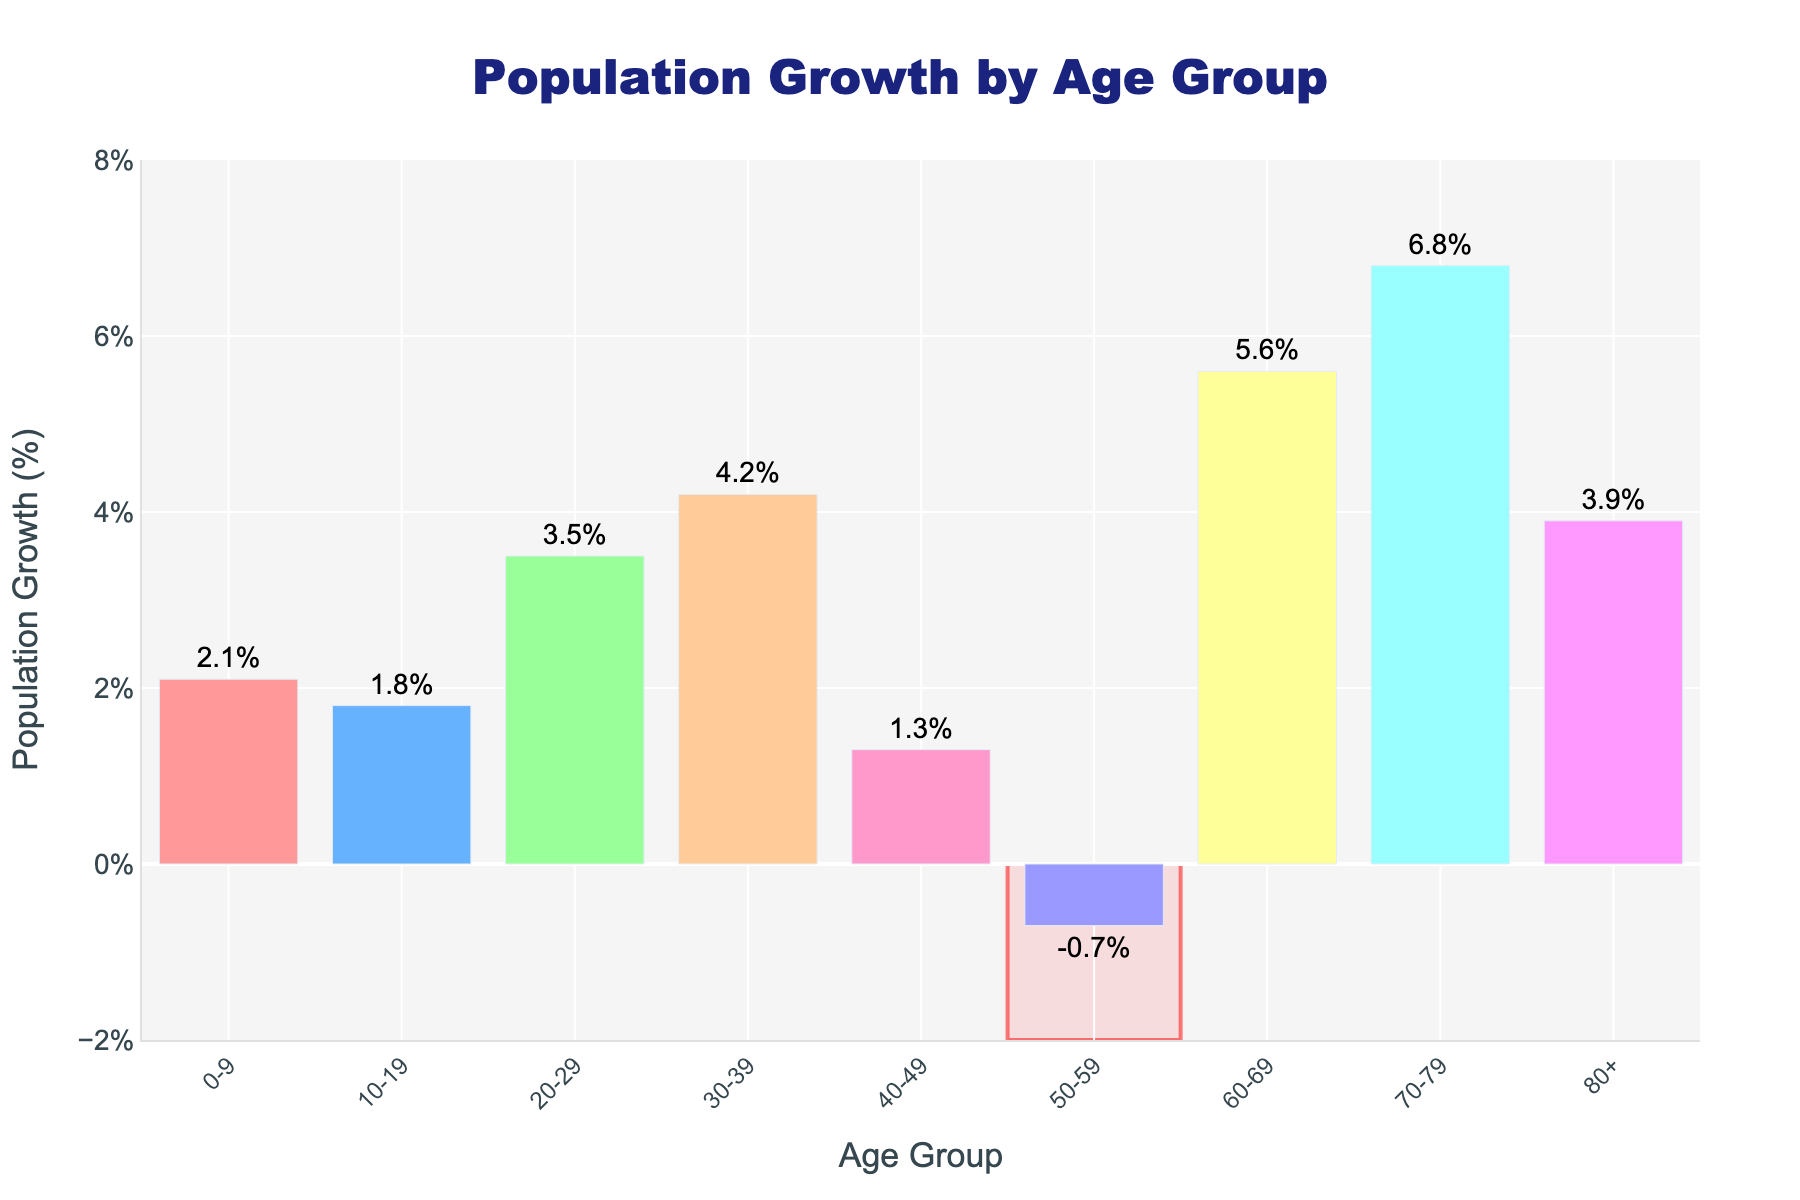Which age group experienced the highest population growth? Refer to the height of the bars and identify the tallest one. The tallest bar represents the age group 70-79.
Answer: 70-79 Which age group experienced a decline in population growth? Look for the bar below the y-axis, indicating a negative value. The bar representing the age group 50-59 is the only one below 0%.
Answer: 50-59 What is the difference in population growth between the age group 30-39 and 40-49? Find the heights of the bars for 30-39 (4.2%) and 40-49 (1.3%). Then, subtract 1.3% from 4.2%.
Answer: 2.9% Which age group had the closest population growth to 4%? Find the bar heights near 4%. The closest one is for the age group 80+, which has a growth of 3.9%.
Answer: 80+ Calculate the average population growth for the age groups 20-29, 30-39, and 40-49. Sum their growth rates (3.5% + 4.2% + 1.3% = 9%) and divide by the number of age groups (9%/3).
Answer: 3% Compare the population growth of the age groups 0-9 and 60-69. Which one had a higher growth rate? Identify the bar heights for 0-9 (2.1%) and 60-69 (5.6%). The bar for 60-69 is taller, meaning its growth rate is higher.
Answer: 60-69 What is the combined population growth percentage for age groups 0-9 and 10-19? Sum their growth rates (2.1% + 1.8%).
Answer: 3.9% How many age groups have a population growth of 3% or more? Count the bars that reach or exceed 3%: 20-29, 30-39, 60-69, 70-79, 80+. There are five age groups.
Answer: 5 Is the population growth rate for the age group 80+ higher or lower than the growth rate for the age group 10-19? Compare their heights: 80+ has a growth rate of 3.9%, while 10-19 has 1.8%. 3.9% is higher than 1.8%.
Answer: Higher What is the range of population growth rates represented in the figure? Find the highest (70-79 at 6.8%) and the lowest (50-59 at -0.7%) values and calculate the difference (6.8% - (-0.7%) = 7.5%).
Answer: 7.5% 